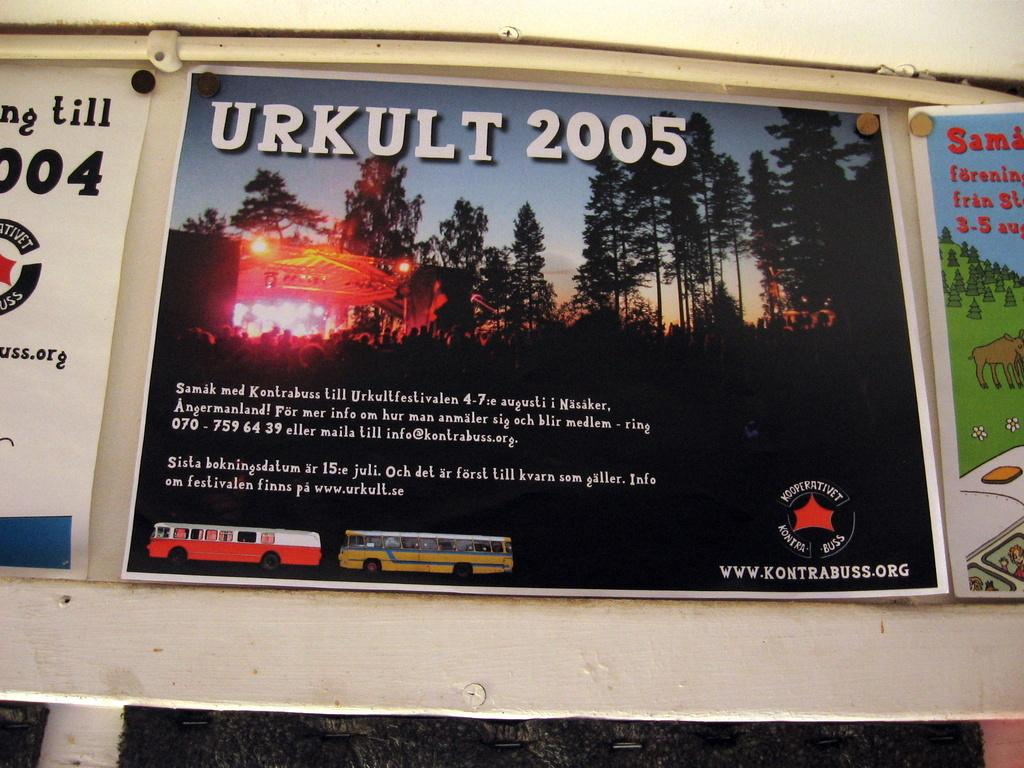<image>
Relay a brief, clear account of the picture shown. A poster for Urkult 2005 has a picture of the forest at sunrise. 